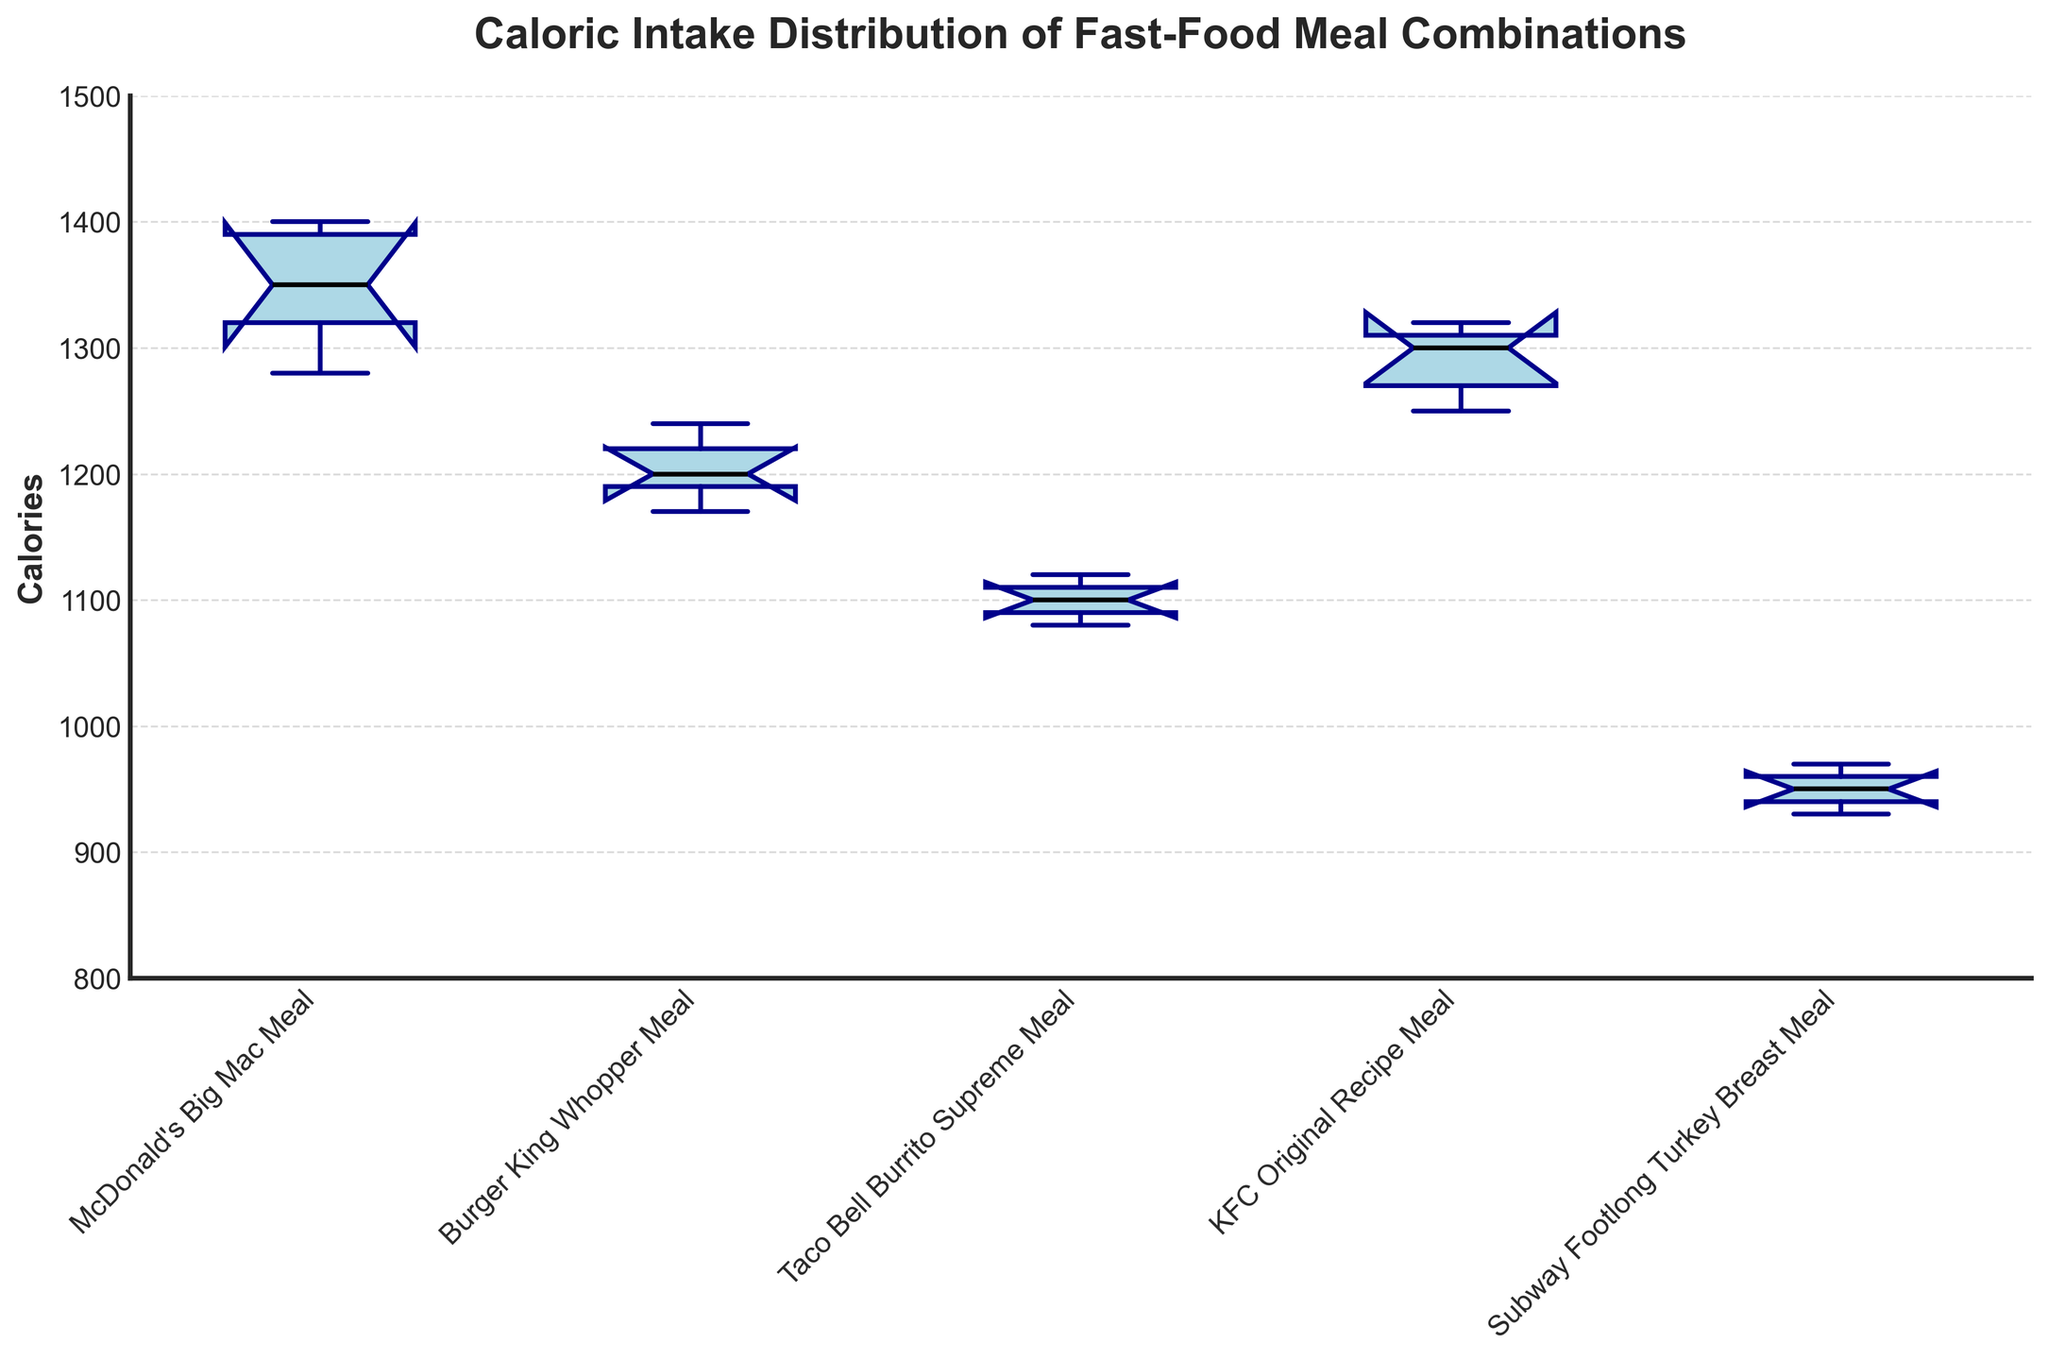what is the title of the figure? The title is typically located at the top of the figure in larger and bold text. This figure's title explicitly states what the box plots represent.
Answer: Caloric Intake Distribution of Fast-Food Meal Combinations What is the median caloric intake for the McDonald's Big Mac Meal? The median is marked by the black line within the box of the McDonald's Big Mac Meal's box plot. You can find this meal's plot by looking at the leftmost box plot on the x-axis.
Answer: Approximately 1350 Which meal combination has the lowest median caloric intake? To find the meal with the lowest median caloric intake, compare the black lines in the center of each box plot. The lowest black line belongs to the lowest median.
Answer: Subway Footlong Turkey Breast Meal How does the median caloric intake of the KFC Original Recipe Meal compare to the Taco Bell Burrito Supreme Meal? Locate the black median lines in the KFC and Taco Bell box plots and compare their vertical positions. KFC's median appears higher than Taco Bell's.
Answer: KFC's median is higher What is the interquartile range (IQR) for the Burger King Whopper Meal? The IQR is represented by the height of the box in each plot, spanning from the lower quartile (25th percentile) to the upper quartile (75th percentile). For the Burger King meal, estimate the range between these percentiles.
Answer: Approximately 70 Which meal combination shows the highest variability in caloric intake? Variability can be assessed by looking at the height of the box and the spread of the whiskers. The taller the box and the longer the whiskers, the higher the variability.
Answer: KFC Original Recipe Meal Are there any outliers in the Subway Footlong Turkey Breast Meal? Outliers are indicated by individual points outside the whiskers of the box plot. Checking the Subway box plot for these points will tell if there are any.
Answer: No Which meal combination has the notch that represents the median closest to the top edge of the box? The notched part of the box plot indicates the median. Comparing the position of these notches relative to the top edge of their respective boxes will answer the question.
Answer: Subway Footlong Turkey Breast Meal 